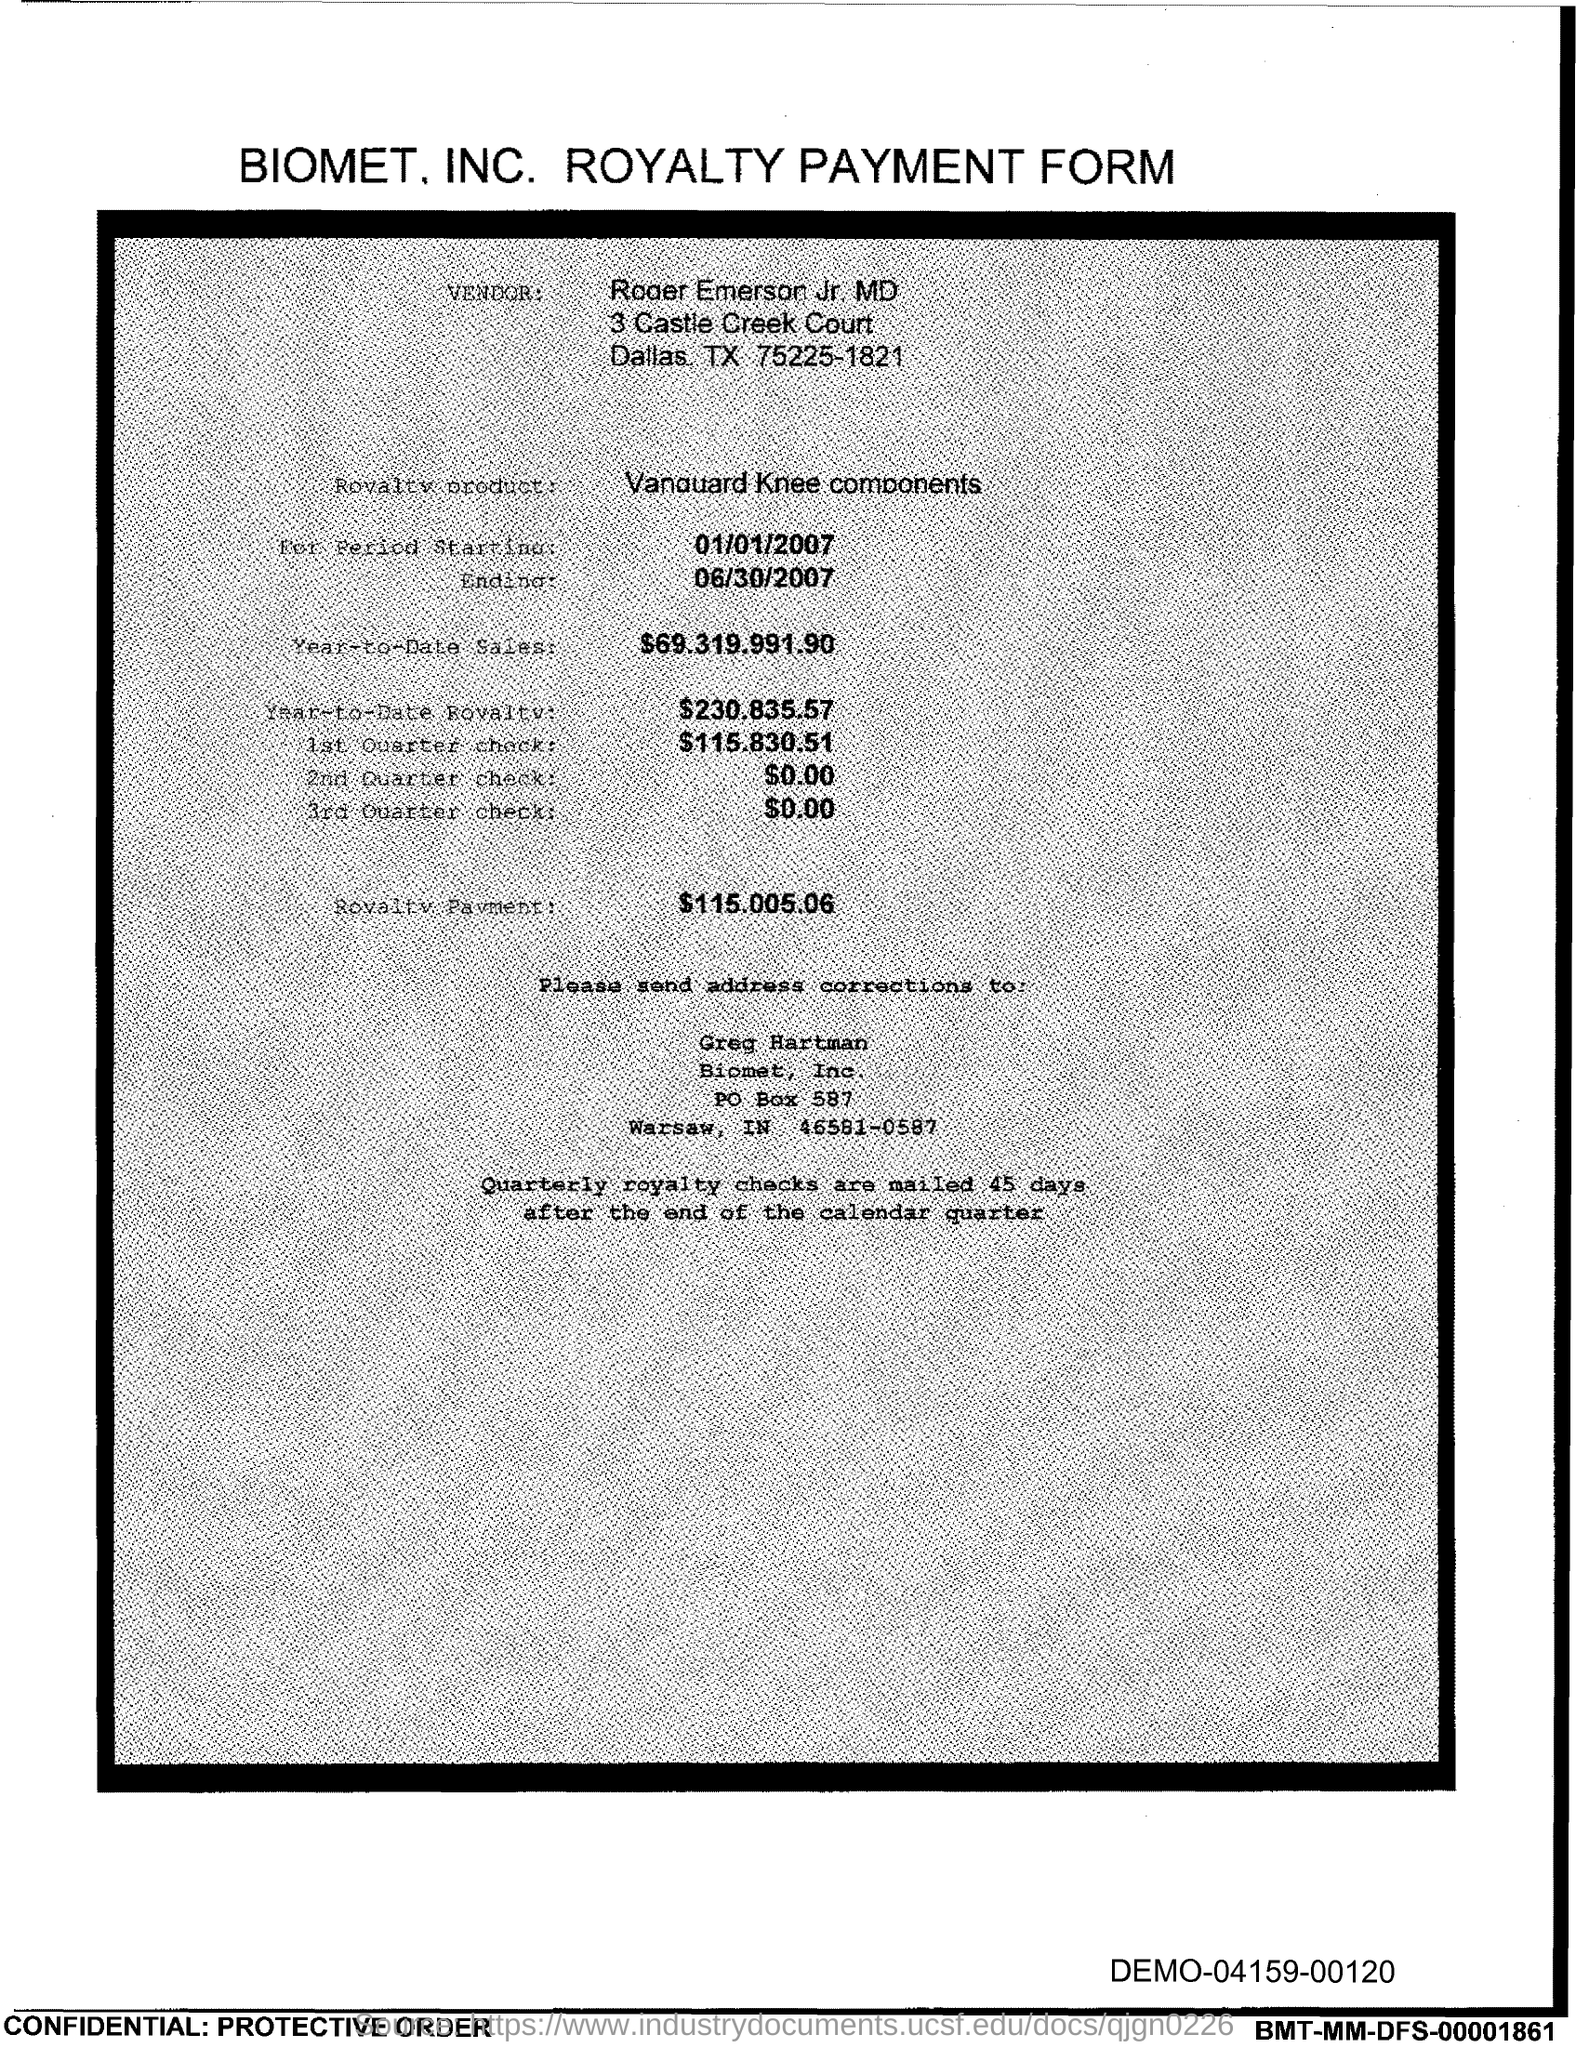Outline some significant characteristics in this image. The document lists a PO Box number of 587. 